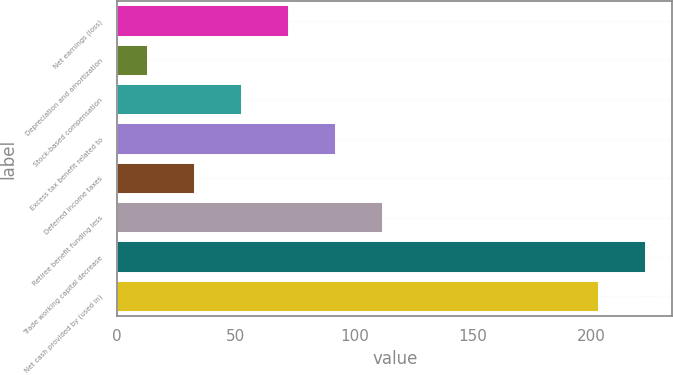Convert chart. <chart><loc_0><loc_0><loc_500><loc_500><bar_chart><fcel>Net earnings (loss)<fcel>Depreciation and amortization<fcel>Stock-based compensation<fcel>Excess tax benefit related to<fcel>Deferred income taxes<fcel>Retiree benefit funding less<fcel>Trade working capital decrease<fcel>Net cash provided by (used in)<nl><fcel>72.4<fcel>13<fcel>52.6<fcel>92.2<fcel>32.8<fcel>112<fcel>222.8<fcel>203<nl></chart> 